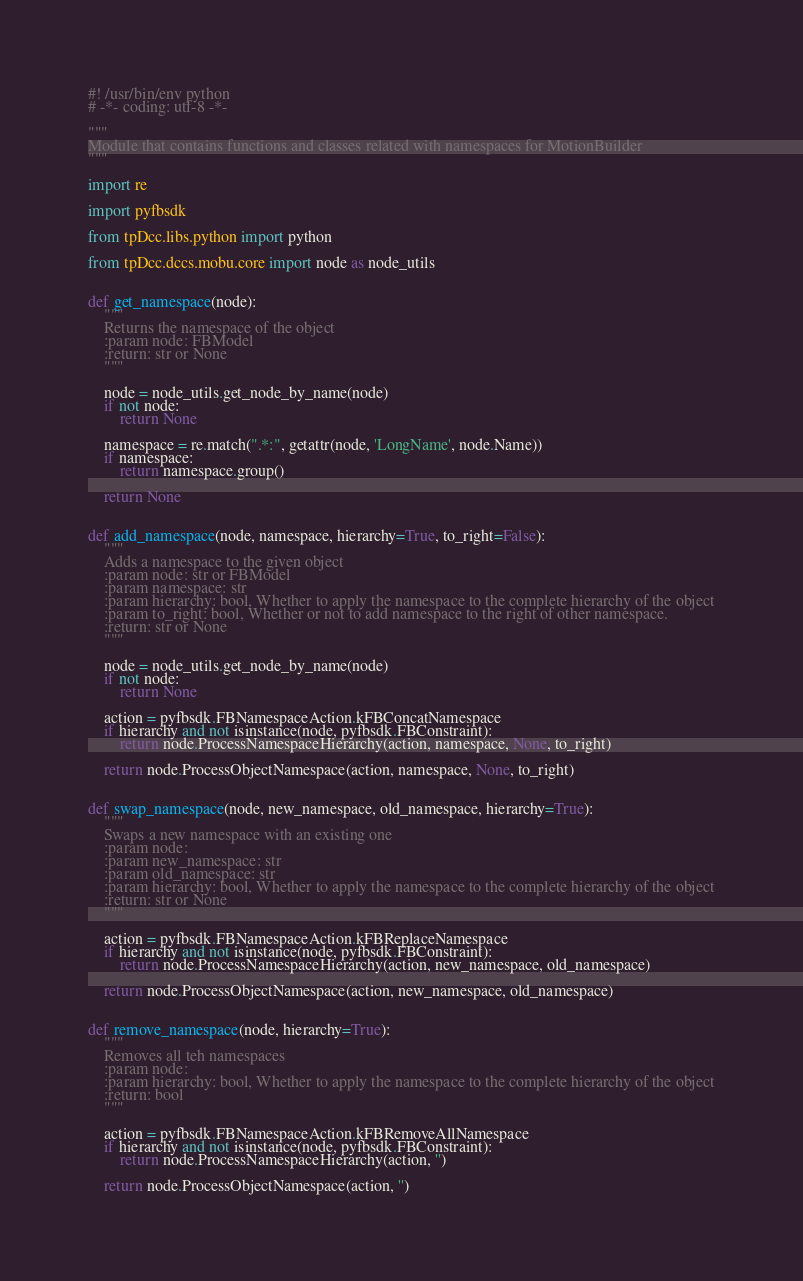Convert code to text. <code><loc_0><loc_0><loc_500><loc_500><_Python_>#! /usr/bin/env python
# -*- coding: utf-8 -*-

"""
Module that contains functions and classes related with namespaces for MotionBuilder
"""

import re

import pyfbsdk

from tpDcc.libs.python import python

from tpDcc.dccs.mobu.core import node as node_utils


def get_namespace(node):
    """
    Returns the namespace of the object
    :param node: FBModel
    :return: str or None
    """

    node = node_utils.get_node_by_name(node)
    if not node:
        return None

    namespace = re.match(".*:", getattr(node, 'LongName', node.Name))
    if namespace:
        return namespace.group()

    return None


def add_namespace(node, namespace, hierarchy=True, to_right=False):
    """
    Adds a namespace to the given object
    :param node: str or FBModel
    :param namespace: str
    :param hierarchy: bool, Whether to apply the namespace to the complete hierarchy of the object
    :param to_right: bool, Whether or not to add namespace to the right of other namespace.
    :return: str or None
    """

    node = node_utils.get_node_by_name(node)
    if not node:
        return None

    action = pyfbsdk.FBNamespaceAction.kFBConcatNamespace
    if hierarchy and not isinstance(node, pyfbsdk.FBConstraint):
        return node.ProcessNamespaceHierarchy(action, namespace, None, to_right)

    return node.ProcessObjectNamespace(action, namespace, None, to_right)


def swap_namespace(node, new_namespace, old_namespace, hierarchy=True):
    """
    Swaps a new namespace with an existing one
    :param node:
    :param new_namespace: str
    :param old_namespace: str
    :param hierarchy: bool, Whether to apply the namespace to the complete hierarchy of the object
    :return: str or None
    """

    action = pyfbsdk.FBNamespaceAction.kFBReplaceNamespace
    if hierarchy and not isinstance(node, pyfbsdk.FBConstraint):
        return node.ProcessNamespaceHierarchy(action, new_namespace, old_namespace)

    return node.ProcessObjectNamespace(action, new_namespace, old_namespace)


def remove_namespace(node, hierarchy=True):
    """
    Removes all teh namespaces
    :param node:
    :param hierarchy: bool, Whether to apply the namespace to the complete hierarchy of the object
    :return: bool
    """

    action = pyfbsdk.FBNamespaceAction.kFBRemoveAllNamespace
    if hierarchy and not isinstance(node, pyfbsdk.FBConstraint):
        return node.ProcessNamespaceHierarchy(action, '')

    return node.ProcessObjectNamespace(action, '')
</code> 